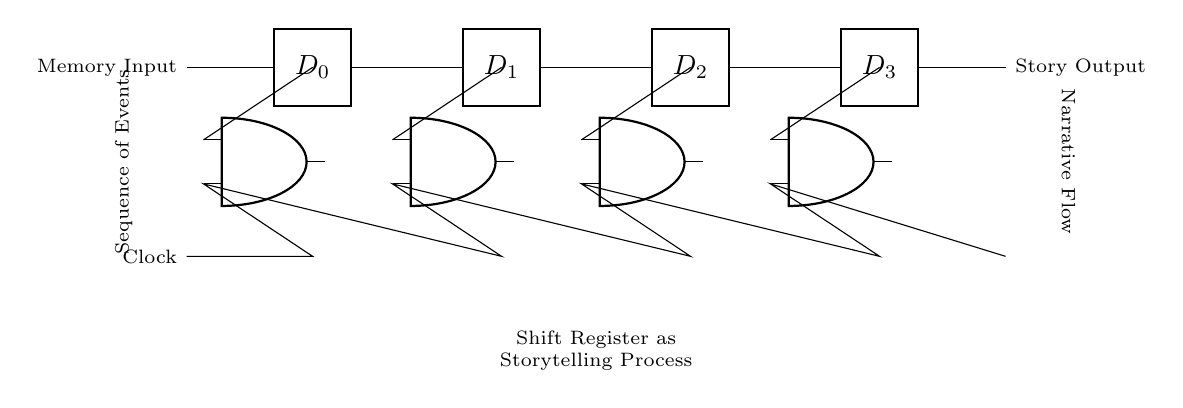What is the output of the shift register? The output refers to the final sequential memory data processed through the shift register. In this diagram, it is symbolized as "Story Output," representing the narrative presented after processing the input memory.
Answer: Story Output How many AND gates are present in the circuit? The number of AND gates is determined by counting the distinct components labeled as AND ports in the diagram. There are four AND gates positioned along the circuit path.
Answer: Four What does the Clock symbolize in this circuit? The Clock in this circuit serves as the timing control that regulates the sequence in which the data bits are shifted through the register. It indicates when each memory event is transferred in the storytelling process.
Answer: Timing control How many data inputs does the shift register have? By examining the circuit, we see that the circuit includes four distinct data inputs labeled D0, D1, D2, and D3, which correspond to the different memory states representing parts of a story.
Answer: Four What is the function of the AND gates in the circuit? The AND gates in this circuit are used to control the flow of data based on the timing signal from the Clock. Specifically, they ensure that the data bits are only passed to the output when the Clock signal is active, facilitating the sequential recall process.
Answer: Control data flow 